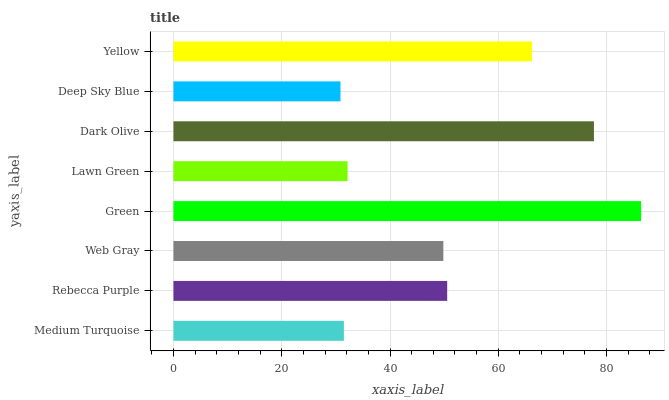Is Deep Sky Blue the minimum?
Answer yes or no. Yes. Is Green the maximum?
Answer yes or no. Yes. Is Rebecca Purple the minimum?
Answer yes or no. No. Is Rebecca Purple the maximum?
Answer yes or no. No. Is Rebecca Purple greater than Medium Turquoise?
Answer yes or no. Yes. Is Medium Turquoise less than Rebecca Purple?
Answer yes or no. Yes. Is Medium Turquoise greater than Rebecca Purple?
Answer yes or no. No. Is Rebecca Purple less than Medium Turquoise?
Answer yes or no. No. Is Rebecca Purple the high median?
Answer yes or no. Yes. Is Web Gray the low median?
Answer yes or no. Yes. Is Lawn Green the high median?
Answer yes or no. No. Is Yellow the low median?
Answer yes or no. No. 